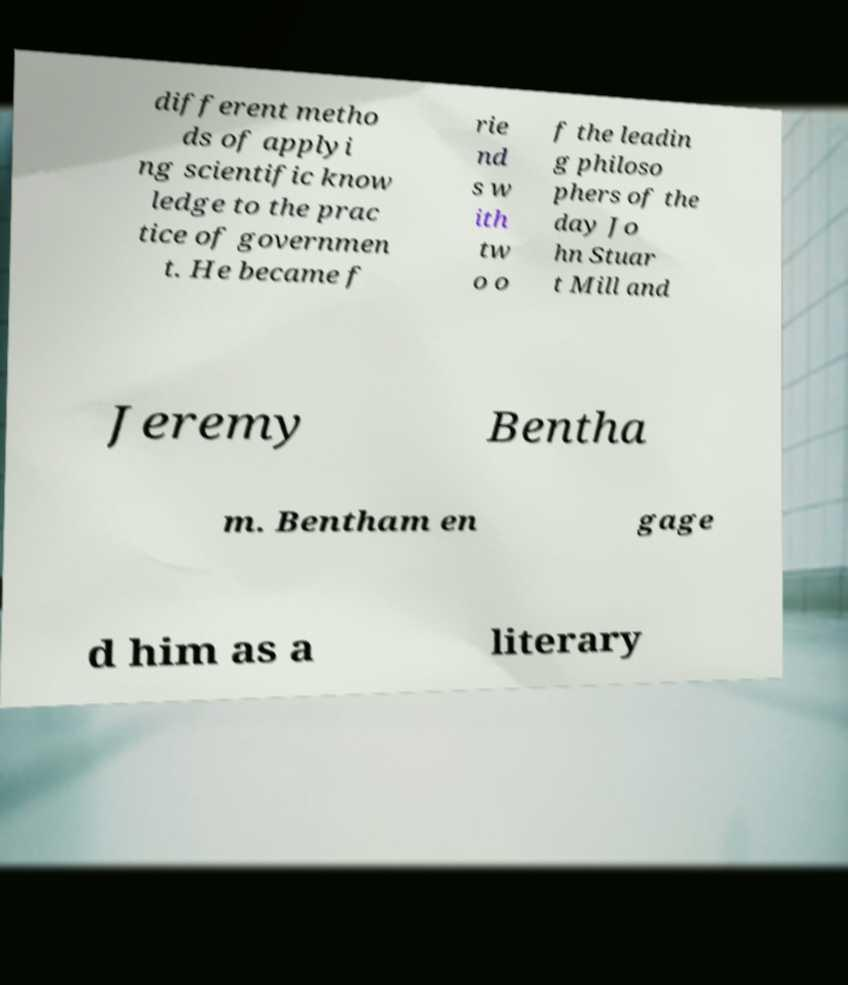Can you read and provide the text displayed in the image?This photo seems to have some interesting text. Can you extract and type it out for me? different metho ds of applyi ng scientific know ledge to the prac tice of governmen t. He became f rie nd s w ith tw o o f the leadin g philoso phers of the day Jo hn Stuar t Mill and Jeremy Bentha m. Bentham en gage d him as a literary 